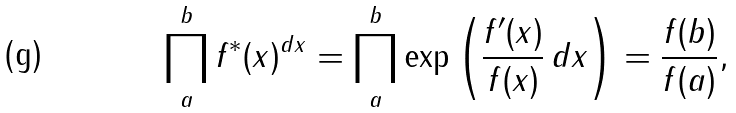Convert formula to latex. <formula><loc_0><loc_0><loc_500><loc_500>\prod _ { a } ^ { b } f ^ { * } ( x ) ^ { d x } = \prod _ { a } ^ { b } \exp \left ( { \frac { f ^ { \prime } ( x ) } { f ( x ) } } \, d x \right ) = { \frac { f ( b ) } { f ( a ) } } ,</formula> 